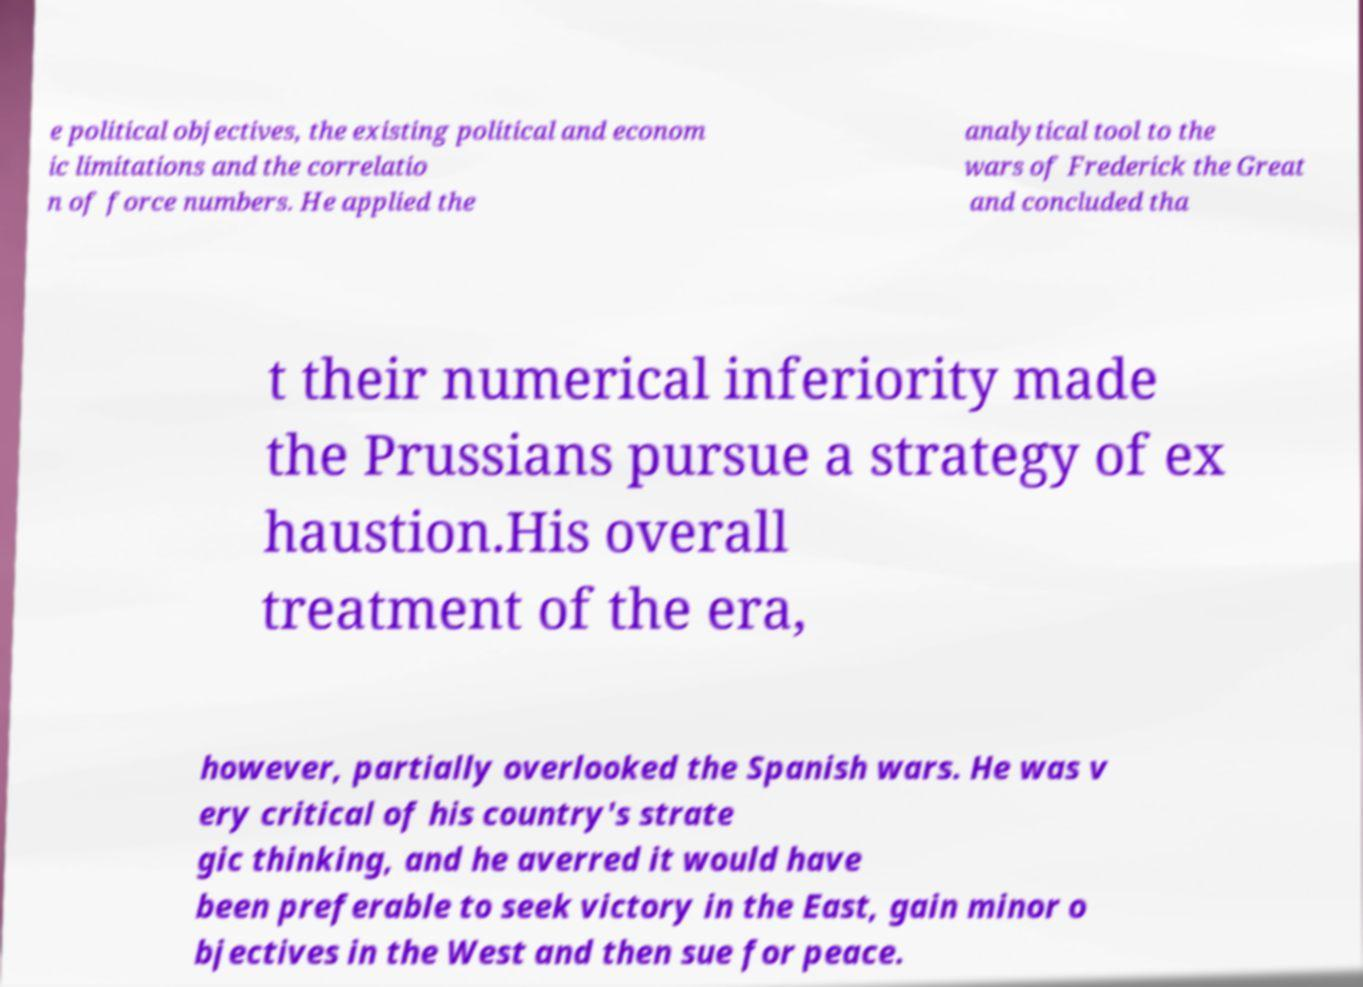Please read and relay the text visible in this image. What does it say? e political objectives, the existing political and econom ic limitations and the correlatio n of force numbers. He applied the analytical tool to the wars of Frederick the Great and concluded tha t their numerical inferiority made the Prussians pursue a strategy of ex haustion.His overall treatment of the era, however, partially overlooked the Spanish wars. He was v ery critical of his country's strate gic thinking, and he averred it would have been preferable to seek victory in the East, gain minor o bjectives in the West and then sue for peace. 